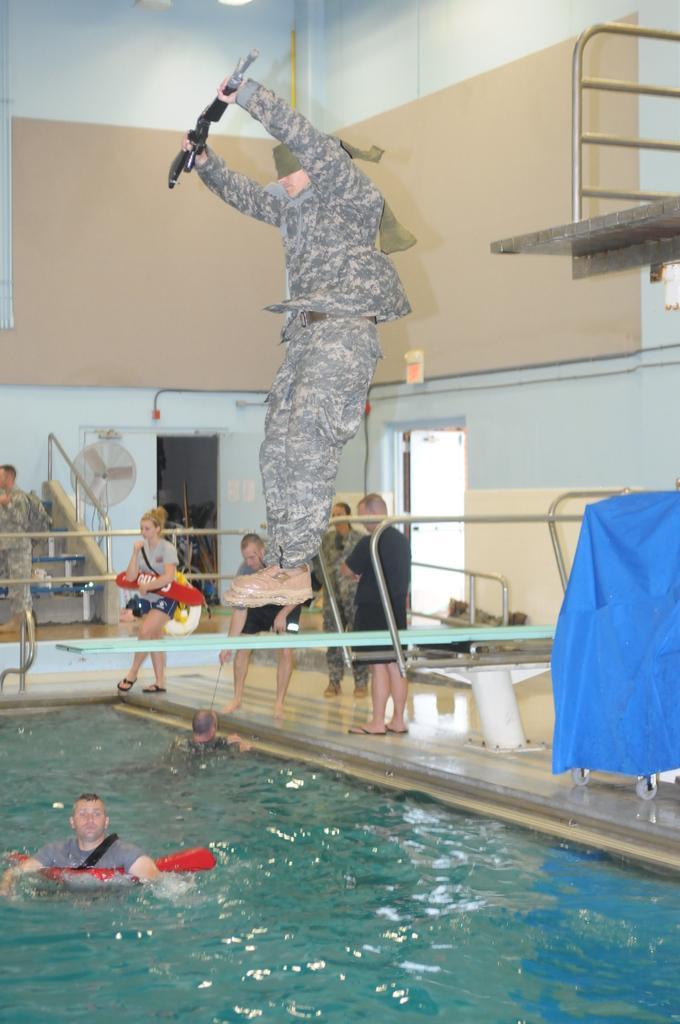How would you summarize this image in a sentence or two? In this picture I can see there is a swimming pool and there are some people in the swimming pool. 